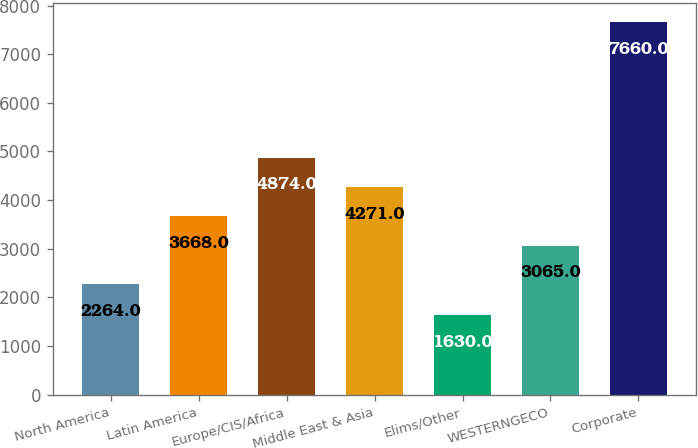Convert chart. <chart><loc_0><loc_0><loc_500><loc_500><bar_chart><fcel>North America<fcel>Latin America<fcel>Europe/CIS/Africa<fcel>Middle East & Asia<fcel>Elims/Other<fcel>WESTERNGECO<fcel>Corporate<nl><fcel>2264<fcel>3668<fcel>4874<fcel>4271<fcel>1630<fcel>3065<fcel>7660<nl></chart> 